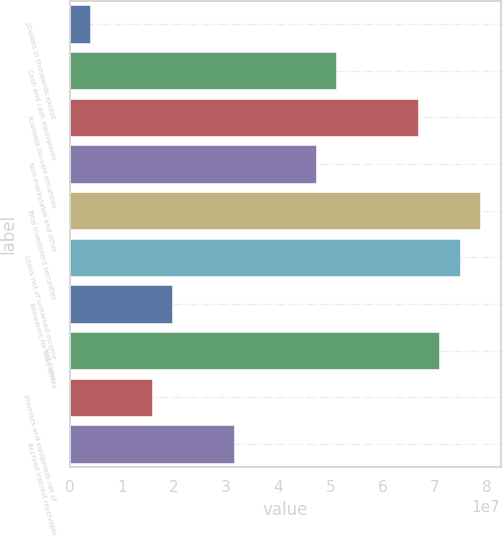<chart> <loc_0><loc_0><loc_500><loc_500><bar_chart><fcel>(Dollars in thousands except<fcel>Cash and cash equivalents<fcel>Available-for-sale securities<fcel>Non-marketable and other<fcel>Total investment securities<fcel>Loans net of unearned income<fcel>Allowance for loan losses<fcel>Net loans<fcel>Premises and equipment net of<fcel>Accrued interest receivable<nl><fcel>3.93451e+06<fcel>5.1148e+07<fcel>6.68859e+07<fcel>4.72136e+07<fcel>7.86892e+07<fcel>7.47548e+07<fcel>1.96723e+07<fcel>7.08203e+07<fcel>1.57379e+07<fcel>3.14757e+07<nl></chart> 